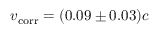Convert formula to latex. <formula><loc_0><loc_0><loc_500><loc_500>v _ { c o r r } = ( 0 . 0 9 \pm 0 . 0 3 ) c</formula> 